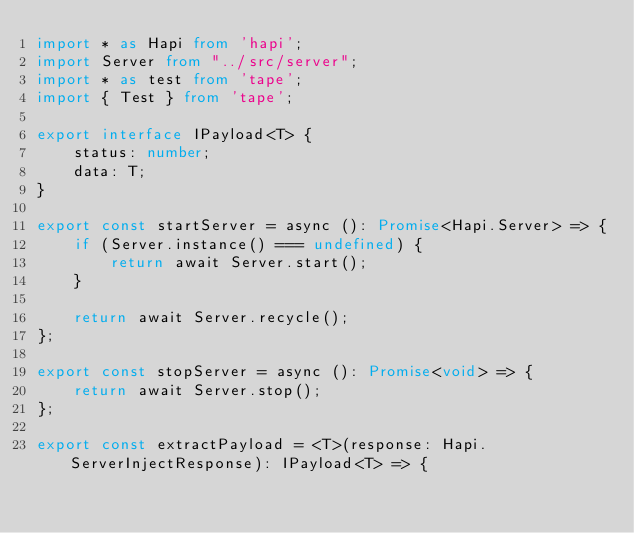<code> <loc_0><loc_0><loc_500><loc_500><_TypeScript_>import * as Hapi from 'hapi';
import Server from "../src/server";
import * as test from 'tape';
import { Test } from 'tape';

export interface IPayload<T> {
    status: number;
    data: T;
}

export const startServer = async (): Promise<Hapi.Server> => {
    if (Server.instance() === undefined) {
        return await Server.start();
    }

    return await Server.recycle();
};

export const stopServer = async (): Promise<void> => {
    return await Server.stop();
};

export const extractPayload = <T>(response: Hapi.ServerInjectResponse): IPayload<T> => {</code> 